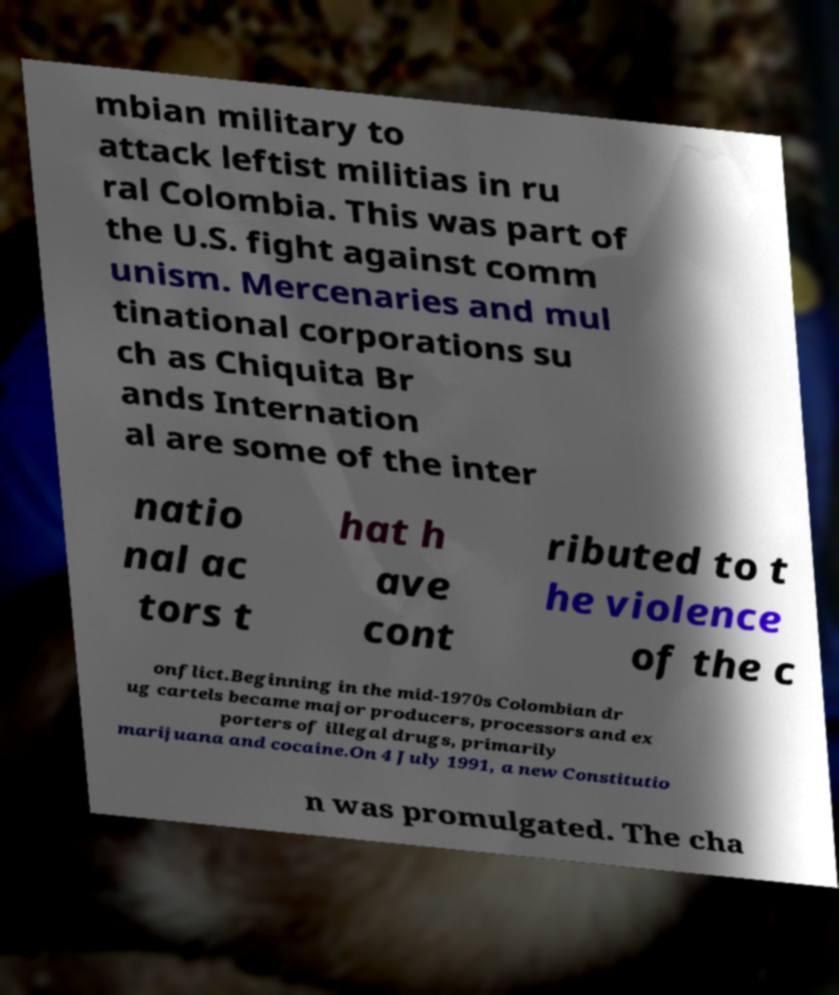Could you extract and type out the text from this image? mbian military to attack leftist militias in ru ral Colombia. This was part of the U.S. fight against comm unism. Mercenaries and mul tinational corporations su ch as Chiquita Br ands Internation al are some of the inter natio nal ac tors t hat h ave cont ributed to t he violence of the c onflict.Beginning in the mid-1970s Colombian dr ug cartels became major producers, processors and ex porters of illegal drugs, primarily marijuana and cocaine.On 4 July 1991, a new Constitutio n was promulgated. The cha 